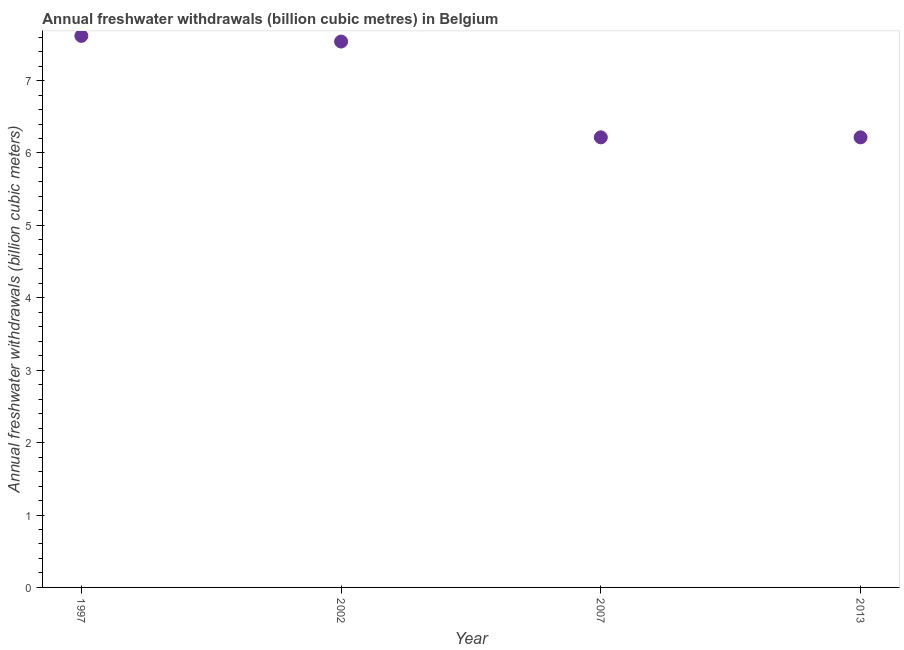What is the annual freshwater withdrawals in 2002?
Offer a terse response. 7.54. Across all years, what is the maximum annual freshwater withdrawals?
Your answer should be very brief. 7.62. Across all years, what is the minimum annual freshwater withdrawals?
Keep it short and to the point. 6.22. In which year was the annual freshwater withdrawals minimum?
Keep it short and to the point. 2007. What is the sum of the annual freshwater withdrawals?
Provide a succinct answer. 27.59. What is the average annual freshwater withdrawals per year?
Give a very brief answer. 6.9. What is the median annual freshwater withdrawals?
Provide a short and direct response. 6.88. In how many years, is the annual freshwater withdrawals greater than 0.8 billion cubic meters?
Offer a very short reply. 4. Do a majority of the years between 1997 and 2007 (inclusive) have annual freshwater withdrawals greater than 6.8 billion cubic meters?
Provide a succinct answer. Yes. What is the ratio of the annual freshwater withdrawals in 2002 to that in 2007?
Keep it short and to the point. 1.21. Is the annual freshwater withdrawals in 2002 less than that in 2007?
Your response must be concise. No. Is the difference between the annual freshwater withdrawals in 2002 and 2013 greater than the difference between any two years?
Your answer should be very brief. No. What is the difference between the highest and the second highest annual freshwater withdrawals?
Give a very brief answer. 0.08. What is the difference between the highest and the lowest annual freshwater withdrawals?
Provide a short and direct response. 1.4. Does the annual freshwater withdrawals monotonically increase over the years?
Ensure brevity in your answer.  No. How many years are there in the graph?
Make the answer very short. 4. Are the values on the major ticks of Y-axis written in scientific E-notation?
Your answer should be very brief. No. Does the graph contain any zero values?
Offer a terse response. No. Does the graph contain grids?
Keep it short and to the point. No. What is the title of the graph?
Give a very brief answer. Annual freshwater withdrawals (billion cubic metres) in Belgium. What is the label or title of the Y-axis?
Offer a very short reply. Annual freshwater withdrawals (billion cubic meters). What is the Annual freshwater withdrawals (billion cubic meters) in 1997?
Your answer should be compact. 7.62. What is the Annual freshwater withdrawals (billion cubic meters) in 2002?
Make the answer very short. 7.54. What is the Annual freshwater withdrawals (billion cubic meters) in 2007?
Keep it short and to the point. 6.22. What is the Annual freshwater withdrawals (billion cubic meters) in 2013?
Give a very brief answer. 6.22. What is the difference between the Annual freshwater withdrawals (billion cubic meters) in 1997 and 2002?
Ensure brevity in your answer.  0.08. What is the difference between the Annual freshwater withdrawals (billion cubic meters) in 1997 and 2007?
Make the answer very short. 1.4. What is the difference between the Annual freshwater withdrawals (billion cubic meters) in 1997 and 2013?
Offer a very short reply. 1.4. What is the difference between the Annual freshwater withdrawals (billion cubic meters) in 2002 and 2007?
Provide a succinct answer. 1.32. What is the difference between the Annual freshwater withdrawals (billion cubic meters) in 2002 and 2013?
Offer a terse response. 1.32. What is the difference between the Annual freshwater withdrawals (billion cubic meters) in 2007 and 2013?
Your answer should be compact. 0. What is the ratio of the Annual freshwater withdrawals (billion cubic meters) in 1997 to that in 2007?
Ensure brevity in your answer.  1.23. What is the ratio of the Annual freshwater withdrawals (billion cubic meters) in 1997 to that in 2013?
Your answer should be very brief. 1.23. What is the ratio of the Annual freshwater withdrawals (billion cubic meters) in 2002 to that in 2007?
Provide a short and direct response. 1.21. What is the ratio of the Annual freshwater withdrawals (billion cubic meters) in 2002 to that in 2013?
Give a very brief answer. 1.21. What is the ratio of the Annual freshwater withdrawals (billion cubic meters) in 2007 to that in 2013?
Provide a short and direct response. 1. 